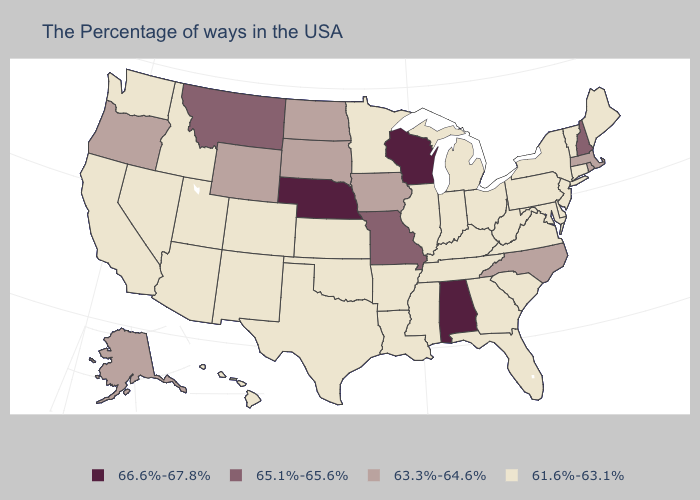Name the states that have a value in the range 63.3%-64.6%?
Give a very brief answer. Massachusetts, Rhode Island, North Carolina, Iowa, South Dakota, North Dakota, Wyoming, Oregon, Alaska. Name the states that have a value in the range 61.6%-63.1%?
Short answer required. Maine, Vermont, Connecticut, New York, New Jersey, Delaware, Maryland, Pennsylvania, Virginia, South Carolina, West Virginia, Ohio, Florida, Georgia, Michigan, Kentucky, Indiana, Tennessee, Illinois, Mississippi, Louisiana, Arkansas, Minnesota, Kansas, Oklahoma, Texas, Colorado, New Mexico, Utah, Arizona, Idaho, Nevada, California, Washington, Hawaii. Does Alabama have the highest value in the South?
Write a very short answer. Yes. Which states have the lowest value in the MidWest?
Be succinct. Ohio, Michigan, Indiana, Illinois, Minnesota, Kansas. Among the states that border Washington , which have the highest value?
Answer briefly. Oregon. Which states hav the highest value in the West?
Be succinct. Montana. Name the states that have a value in the range 65.1%-65.6%?
Quick response, please. New Hampshire, Missouri, Montana. Does the map have missing data?
Concise answer only. No. What is the lowest value in the USA?
Short answer required. 61.6%-63.1%. Does Massachusetts have the lowest value in the USA?
Concise answer only. No. Among the states that border Maryland , which have the lowest value?
Short answer required. Delaware, Pennsylvania, Virginia, West Virginia. What is the lowest value in the Northeast?
Write a very short answer. 61.6%-63.1%. Name the states that have a value in the range 66.6%-67.8%?
Answer briefly. Alabama, Wisconsin, Nebraska. What is the lowest value in states that border Maine?
Short answer required. 65.1%-65.6%. 